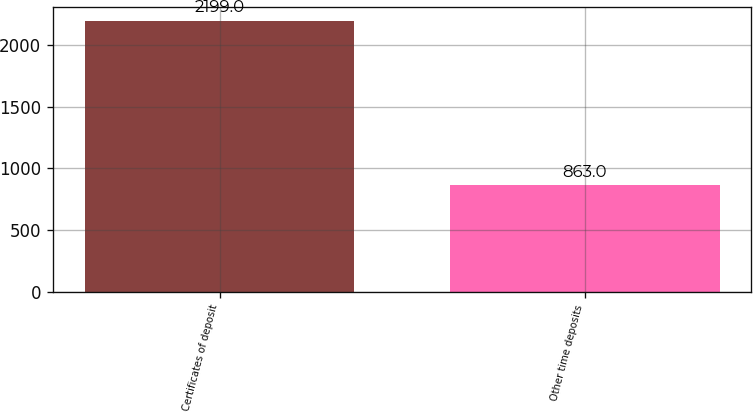Convert chart. <chart><loc_0><loc_0><loc_500><loc_500><bar_chart><fcel>Certificates of deposit<fcel>Other time deposits<nl><fcel>2199<fcel>863<nl></chart> 